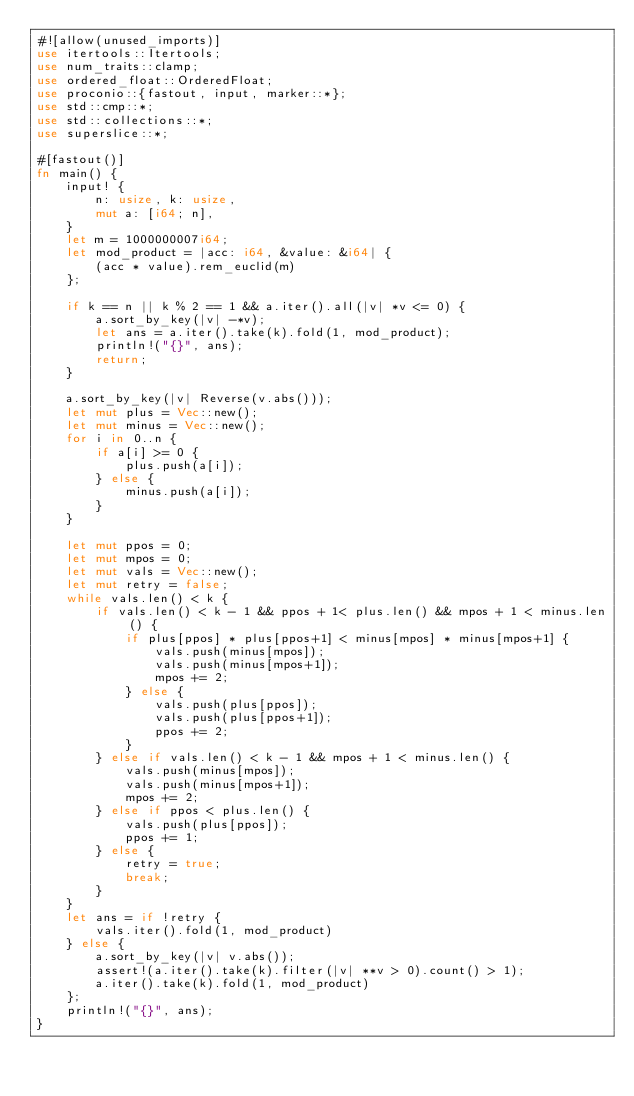Convert code to text. <code><loc_0><loc_0><loc_500><loc_500><_Rust_>#![allow(unused_imports)]
use itertools::Itertools;
use num_traits::clamp;
use ordered_float::OrderedFloat;
use proconio::{fastout, input, marker::*};
use std::cmp::*;
use std::collections::*;
use superslice::*;

#[fastout()]
fn main() {
    input! {
        n: usize, k: usize,
        mut a: [i64; n],
    }
    let m = 1000000007i64;
    let mod_product = |acc: i64, &value: &i64| {
        (acc * value).rem_euclid(m)
    };

    if k == n || k % 2 == 1 && a.iter().all(|v| *v <= 0) {
        a.sort_by_key(|v| -*v);
        let ans = a.iter().take(k).fold(1, mod_product);
        println!("{}", ans);
        return;
    }

    a.sort_by_key(|v| Reverse(v.abs()));
    let mut plus = Vec::new();
    let mut minus = Vec::new();
    for i in 0..n {
        if a[i] >= 0 {
            plus.push(a[i]);
        } else {
            minus.push(a[i]);
        }
    }

    let mut ppos = 0;
    let mut mpos = 0;
    let mut vals = Vec::new();
    let mut retry = false;
    while vals.len() < k {
        if vals.len() < k - 1 && ppos + 1< plus.len() && mpos + 1 < minus.len() {
            if plus[ppos] * plus[ppos+1] < minus[mpos] * minus[mpos+1] {
                vals.push(minus[mpos]);
                vals.push(minus[mpos+1]);
                mpos += 2;
            } else {
                vals.push(plus[ppos]);
                vals.push(plus[ppos+1]);
                ppos += 2;
            }
        } else if vals.len() < k - 1 && mpos + 1 < minus.len() {
            vals.push(minus[mpos]);
            vals.push(minus[mpos+1]);
            mpos += 2;
        } else if ppos < plus.len() {
            vals.push(plus[ppos]);
            ppos += 1;
        } else {
            retry = true;
            break;
        }
    }
    let ans = if !retry {
        vals.iter().fold(1, mod_product)
    } else {
        a.sort_by_key(|v| v.abs());
        assert!(a.iter().take(k).filter(|v| **v > 0).count() > 1);
        a.iter().take(k).fold(1, mod_product)
    };
    println!("{}", ans);
}
</code> 